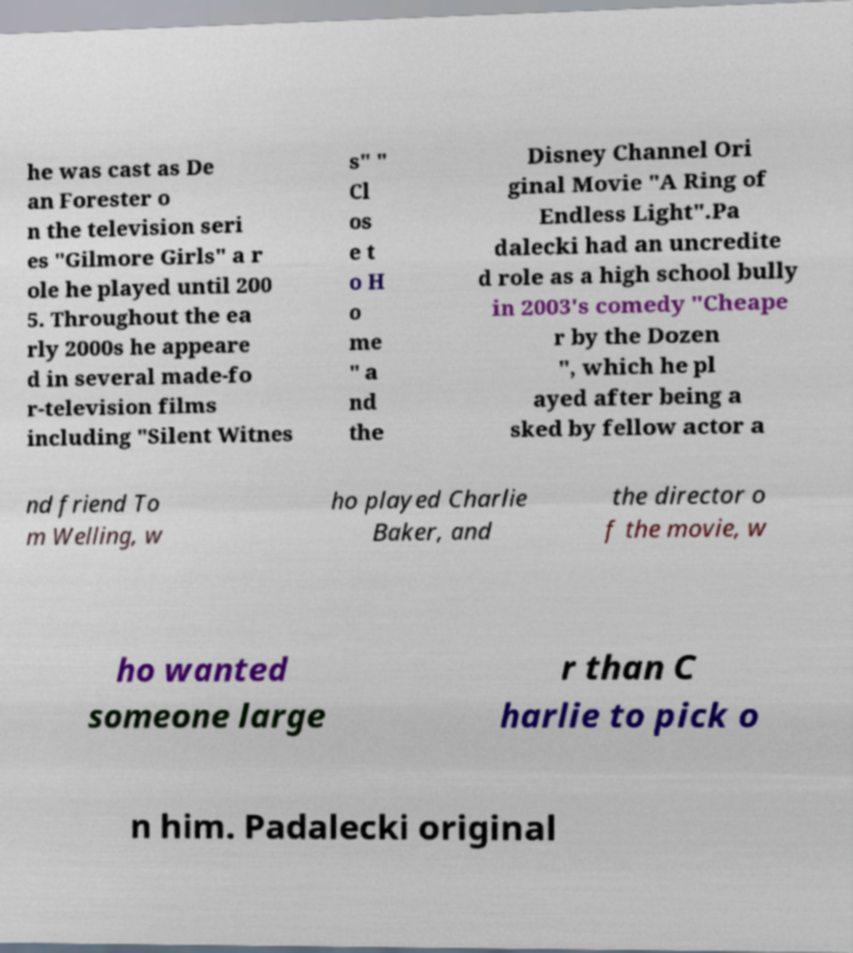Please identify and transcribe the text found in this image. he was cast as De an Forester o n the television seri es "Gilmore Girls" a r ole he played until 200 5. Throughout the ea rly 2000s he appeare d in several made-fo r-television films including "Silent Witnes s" " Cl os e t o H o me " a nd the Disney Channel Ori ginal Movie "A Ring of Endless Light".Pa dalecki had an uncredite d role as a high school bully in 2003's comedy "Cheape r by the Dozen ", which he pl ayed after being a sked by fellow actor a nd friend To m Welling, w ho played Charlie Baker, and the director o f the movie, w ho wanted someone large r than C harlie to pick o n him. Padalecki original 